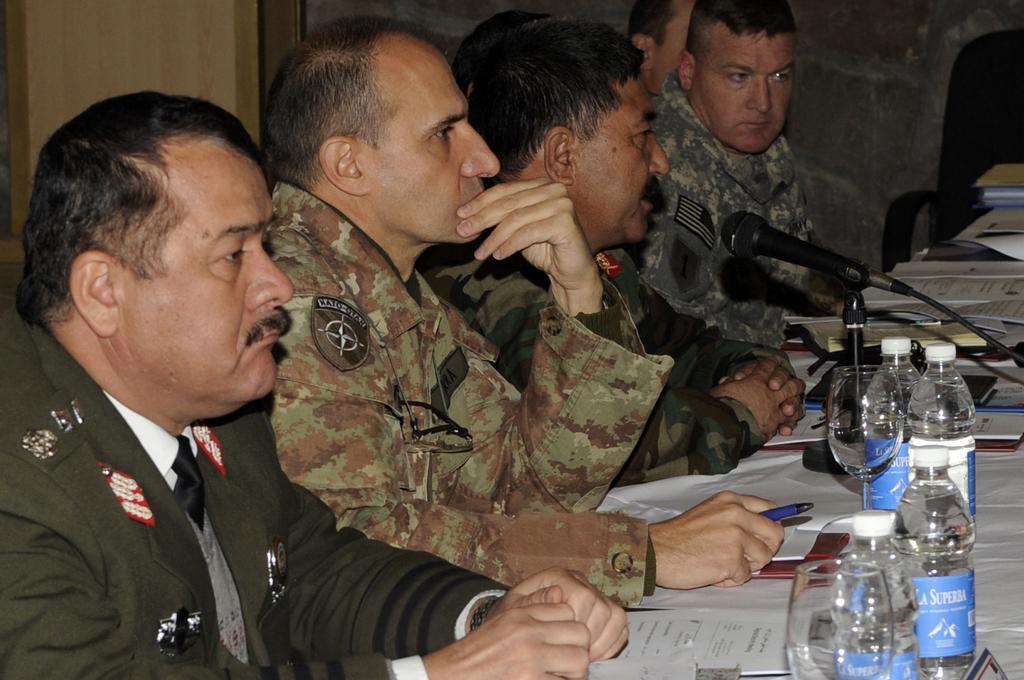How would you summarize this image in a sentence or two? In this picture I can see group of people sitting, there are papers, wine glasses, mike, bottles and some other objects on the table and there is a chair. 